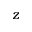<formula> <loc_0><loc_0><loc_500><loc_500>\boldsymbol z</formula> 